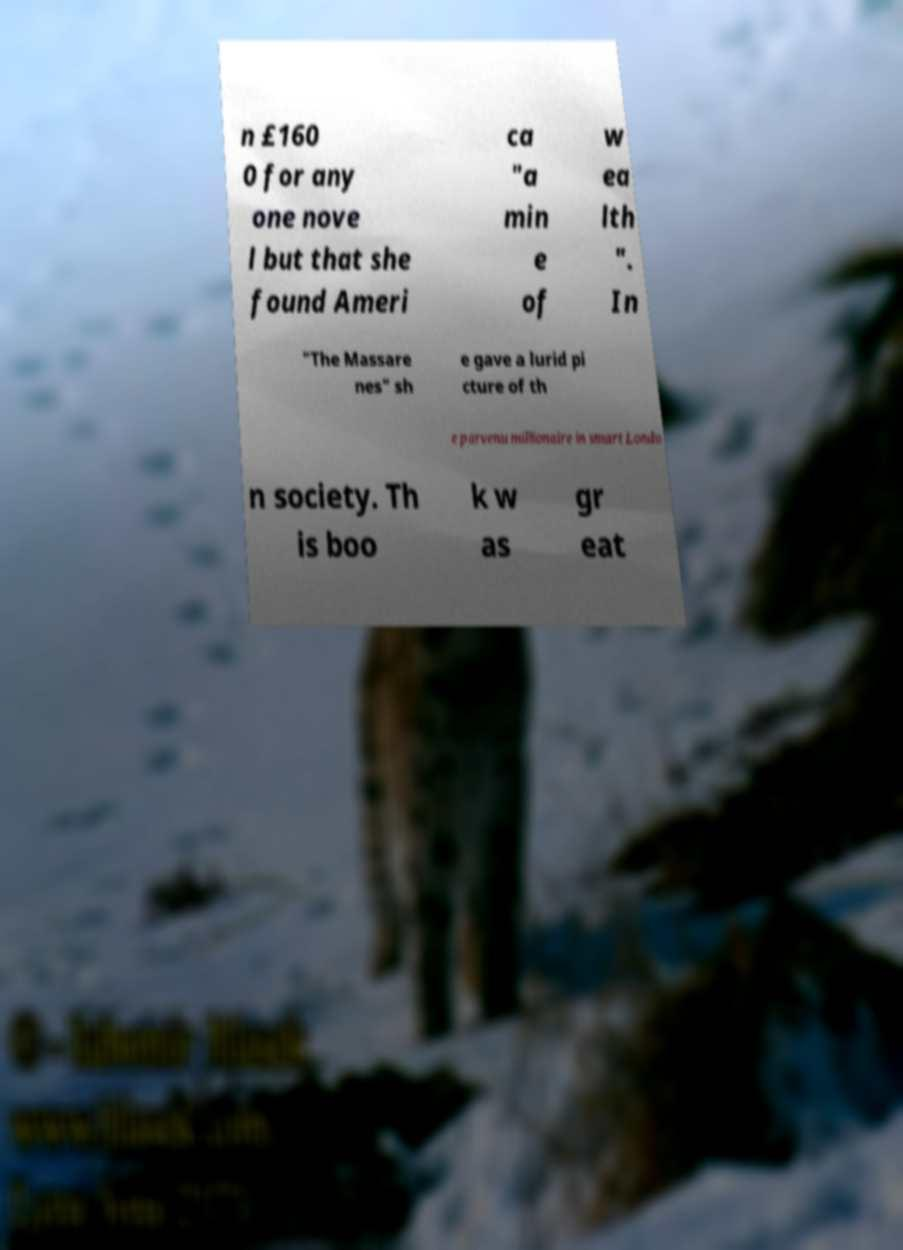Can you accurately transcribe the text from the provided image for me? n £160 0 for any one nove l but that she found Ameri ca "a min e of w ea lth ". In "The Massare nes" sh e gave a lurid pi cture of th e parvenu millionaire in smart Londo n society. Th is boo k w as gr eat 